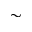Convert formula to latex. <formula><loc_0><loc_0><loc_500><loc_500>\sim</formula> 